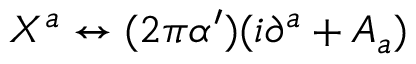<formula> <loc_0><loc_0><loc_500><loc_500>X ^ { a } \leftrightarrow ( 2 \pi \alpha ^ { \prime } ) ( i \partial ^ { a } + A _ { a } )</formula> 